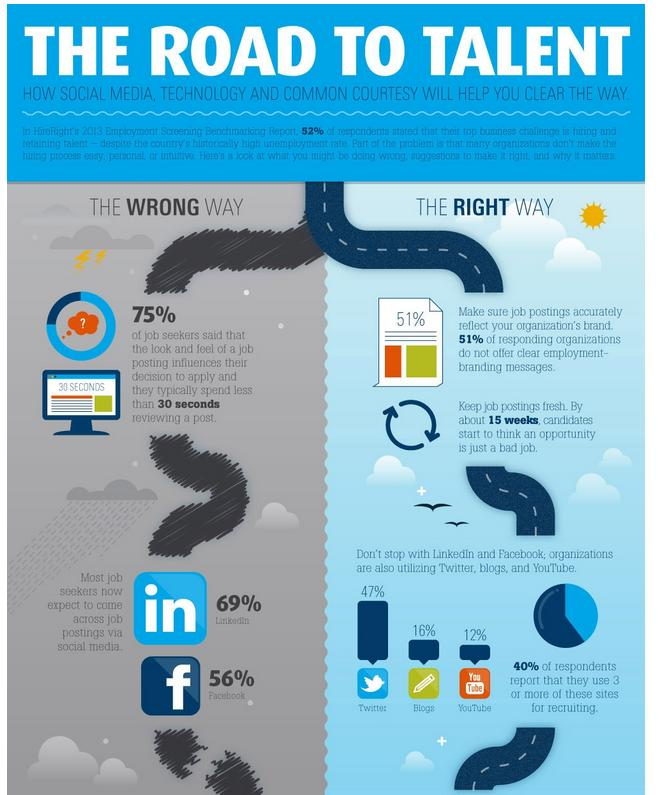Indicate a few pertinent items in this graphic. According to the survey, 16% of respondents reported using blogs for recruiting purposes. According to the survey, 12% of respondents reported using YouTube for recruiting purposes. According to a survey, 56% of jobseekers discovered job postings on Facebook. According to a survey, the majority of job seekers come across job postings on LinkedIn, a popular job site. According to the survey, 47% of respondents report using Twitter for recruiting purposes. 